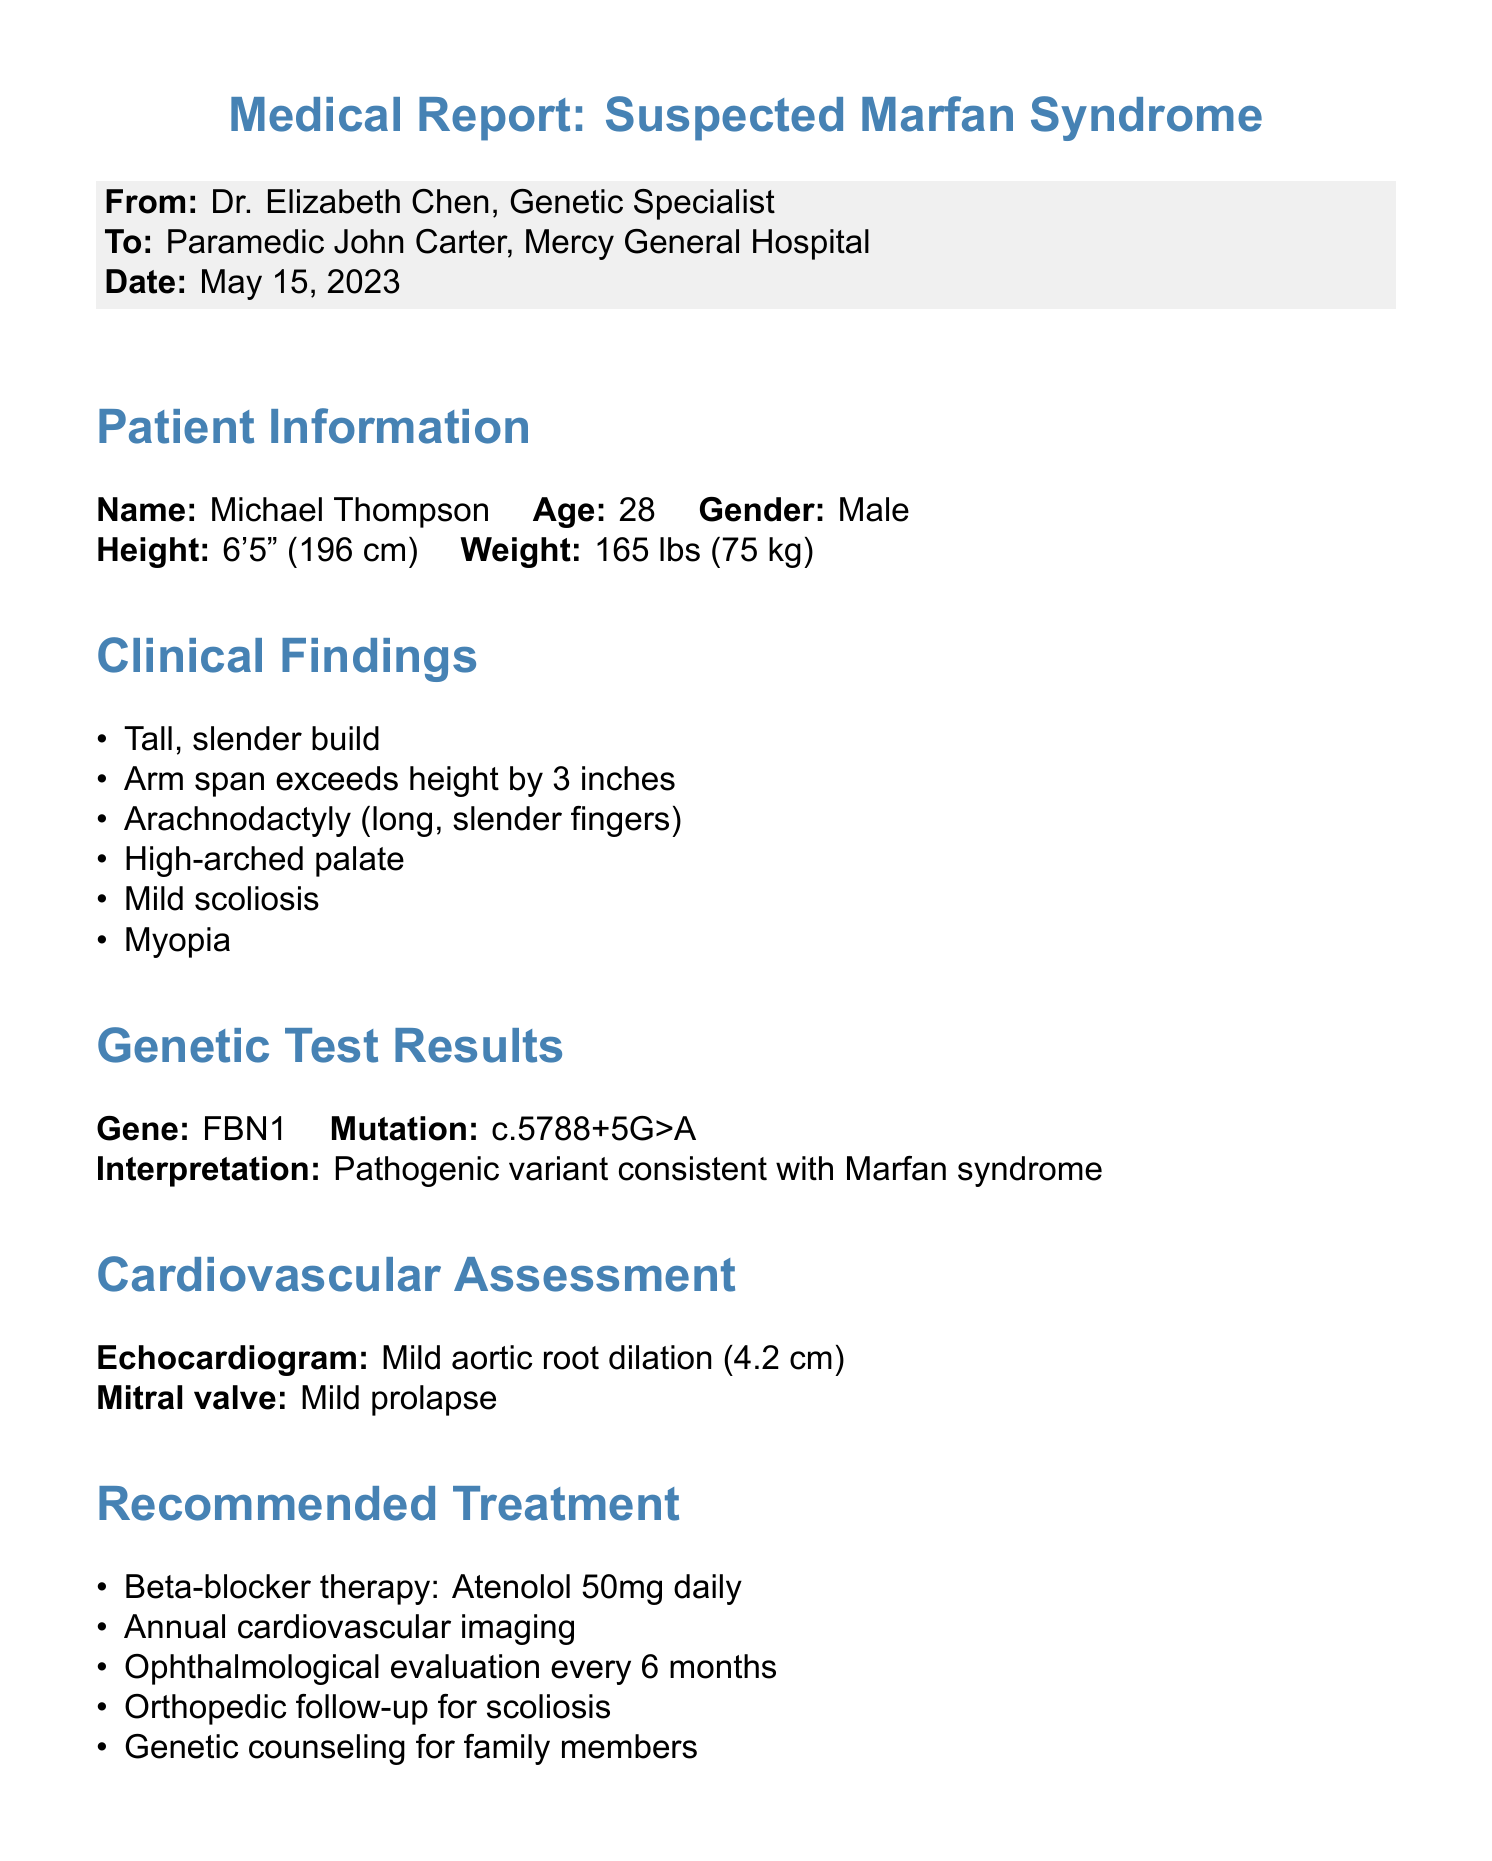What is the patient’s name? The patient's name is provided in the patient information section of the document.
Answer: Michael Thompson What is the age of the patient? The patient's age is listed under the patient information section.
Answer: 28 What is the mutation found in the genetic test? The mutation is specified in the genetic test results section of the document.
Answer: c.5788+5G>A What is the size of the aortic root dilation noted in the cardiovascular assessment? The size of the aortic root dilation is mentioned in the cardiovascular assessment section.
Answer: 4.2 cm What treatment is recommended daily for this patient? The recommended treatment is detailed in the recommended treatment section.
Answer: Atenolol 50mg daily How often should cardiovascular imaging be conducted according to the recommendations? The frequency of cardiovascular imaging is stated in the recommended treatment section.
Answer: Annual What condition is the patient advised to avoid in lifestyle recommendations? The advised condition to avoid is specified in the lifestyle recommendations section.
Answer: Contact sports Who authored this medical report? The author of the report is mentioned at the beginning of the document.
Answer: Dr. Elizabeth Chen When should the follow-up appointment be scheduled? The follow-up appointment is noted at the end of the document.
Answer: In 3 months 